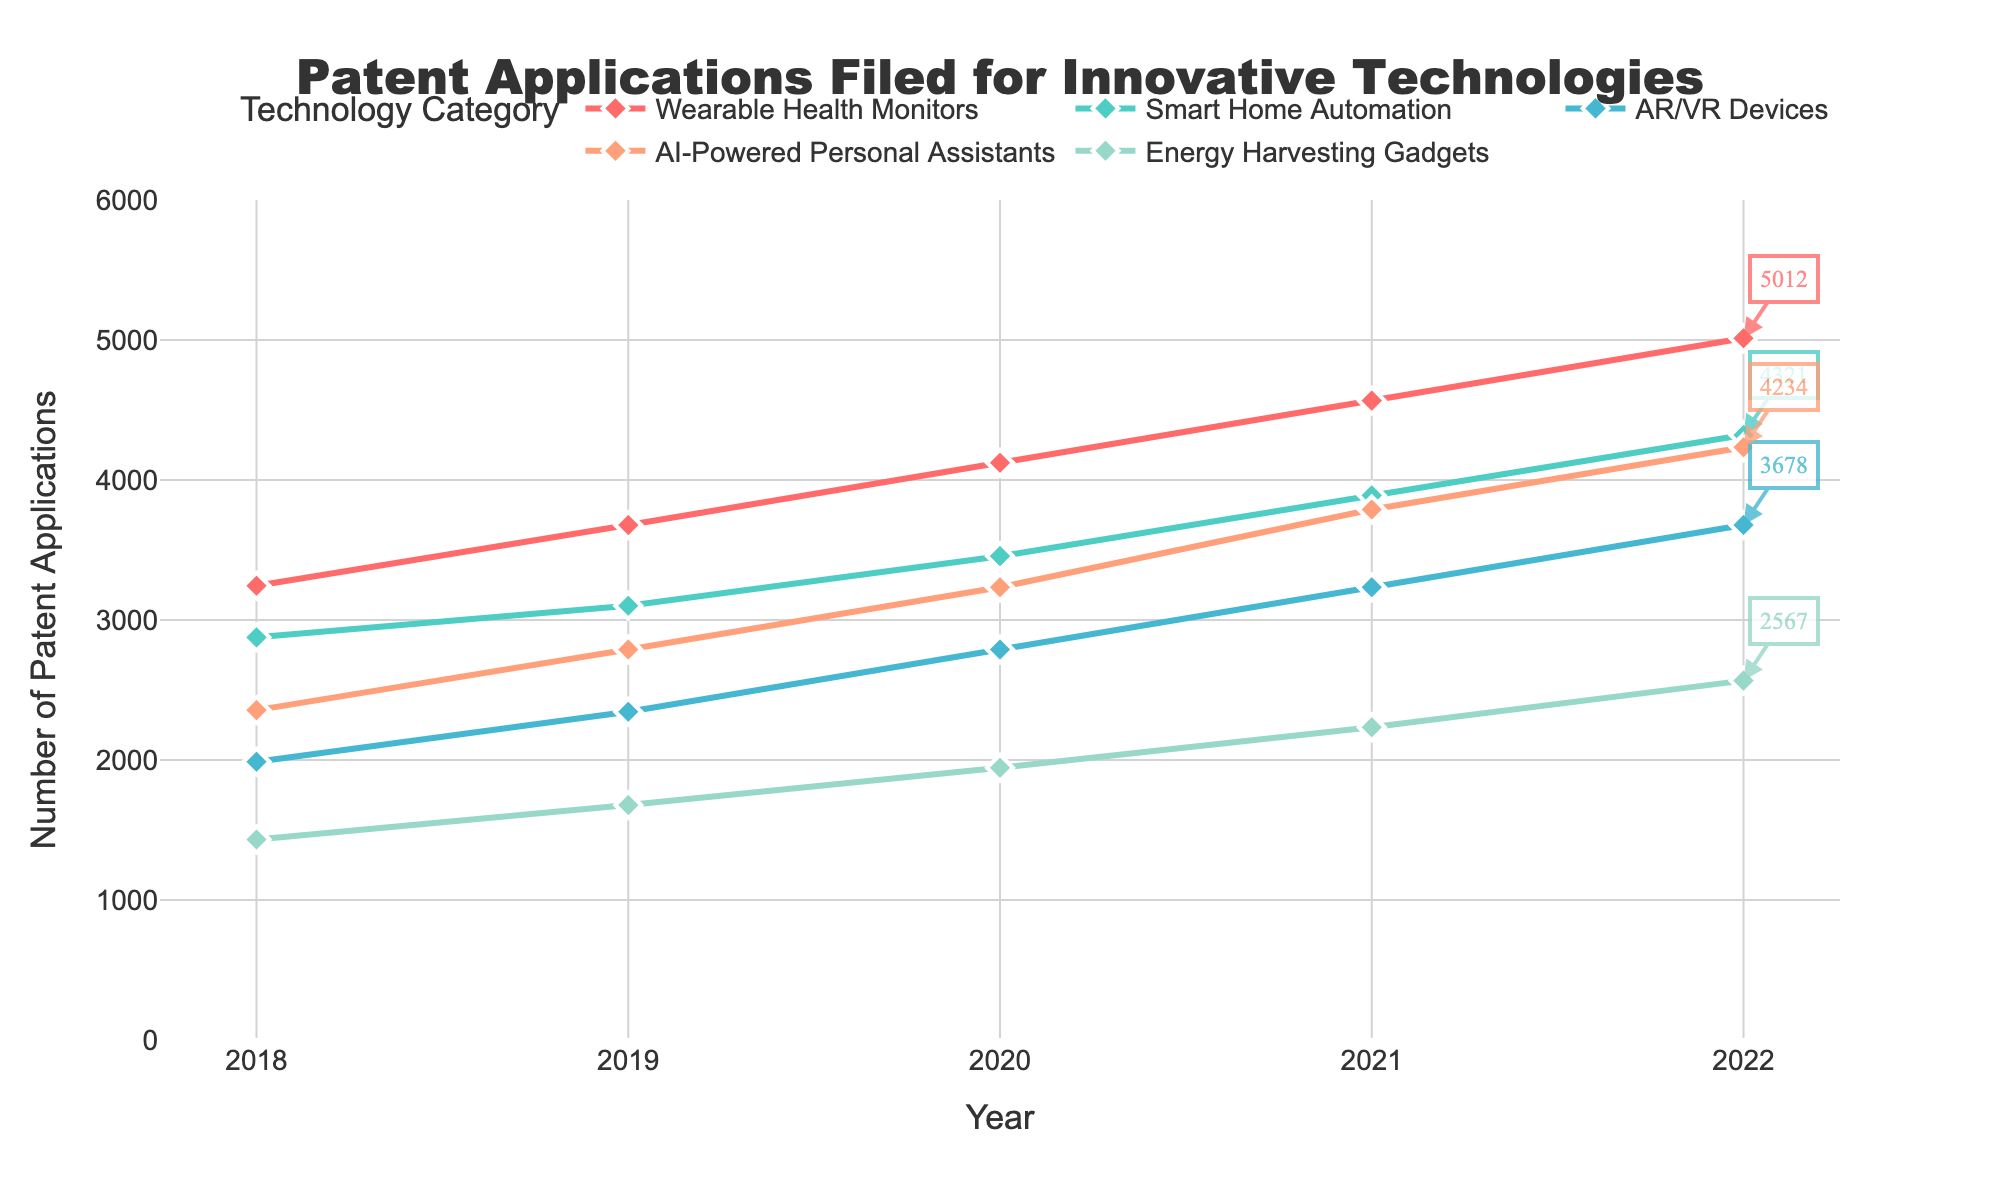What is the trend for the patent applications filed for Wearable Health Monitors over the last five years? The trend for Wearable Health Monitors shows a steady increase each year. Starting from 3245 in 2018, it rose to 3678 in 2019, 4123 in 2020, 4567 in 2021, and peaked at 5012 in 2022. The consistent upward movement indicates growing interest and development in this sector.
Answer: Increasing Which technology category had the highest number of patent applications in 2022? In 2022, the technology category with the highest number of patent applications was Wearable Health Monitors with 5012 applications, as indicated by the highest point on the plot for that year.
Answer: Wearable Health Monitors How do the patent applications filed for Smart Home Automation compare between 2018 and 2022? In 2018, Smart Home Automation had 2876 patent applications filed. By 2022, this number increased to 4321. The difference can be calculated as 4321 - 2876 = 1445, showing a significant growth over the five years.
Answer: Increased by 1445 What is the average number of patent applications filed per year for AI-Powered Personal Assistants over the five-year period? The total applications for AI-Powered Personal Assistants over the five years are: 2356 + 2789 + 3234 + 3789 + 4234 = 16392. To find the average, divide this sum by 5, yielding an average of 16392 / 5 = 3278.4 per year.
Answer: 3278.4 Which technology category showed the greatest relative increase in patent applications from 2018 to 2022? Wearable Health Monitors had 3245 applications in 2018 and 5012 in 2022, an increase of (5012 - 3245) / 3245 = 54.5%. Comparatively, other categories had smaller percentage increases. Therefore, Wearable Health Monitors showed the greatest relative increase.
Answer: Wearable Health Monitors In which year did AR/VR Devices see the highest growth in patent applications, and how much did it grow by that year? The patent applications for AR/VR Devices grew the most from 2018 to 2019, increasing from 1987 to 2345. This growth is calculated as 2345 - 1987 = 358.
Answer: 2019, by 358 What is the combined total of patent applications filed across all categories in the year 2020? The combined total for 2020 is calculated by summing up all application numbers: 4123 (Wearable Health Monitors) + 3456 (Smart Home Automation) + 2789 (AR/VR Devices) + 3234 (AI-Powered Personal Assistants) + 1945 (Energy Harvesting Gadgets) = 15547.
Answer: 15547 Which category had the least number of patent applications in 2021, and how many applications were filed? In 2021, Energy Harvesting Gadgets had the least number of filed patent applications, which was 2234. This can be identified by looking at the lowest point among the categories for that year.
Answer: Energy Harvesting Gadgets, 2234 What is the total increase in patent applications for AI-Powered Personal Assistants from 2018 to 2022? The applications for AI-Powered Personal Assistants were 2356 in 2018 and 4234 in 2022. The total increase is calculated as 4234 - 2356 = 1878.
Answer: 1878 